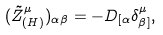<formula> <loc_0><loc_0><loc_500><loc_500>( \tilde { Z } _ { ( H ) } ^ { \mu } ) _ { \alpha \beta } = - D _ { [ \alpha } \delta _ { \beta ] } ^ { \mu } ,</formula> 